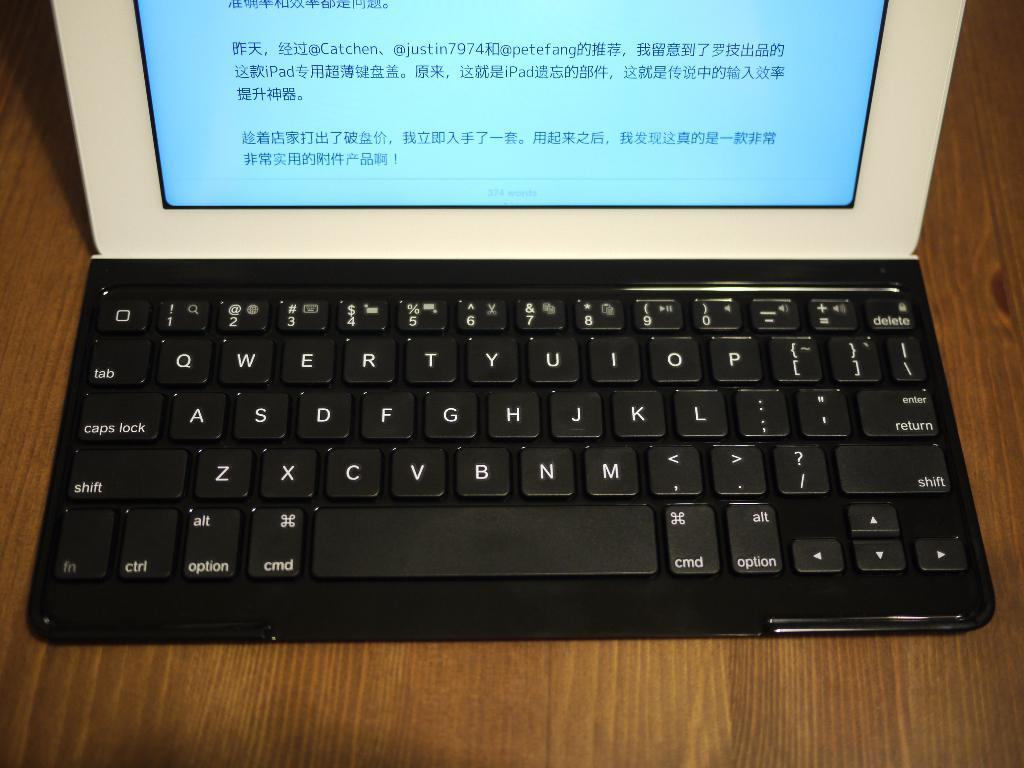What electronic device is visible in the image? There is a laptop in the image. What is the laptop placed on in the image? The laptop is on a wooden surface. What type of arch can be seen in the background of the image? There is no arch present in the image; it only features a laptop on a wooden surface. What sound can be heard coming from the bells in the image? There are no bells present in the image, so it's not possible to determine what sound might be heard. 